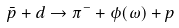<formula> <loc_0><loc_0><loc_500><loc_500>\bar { p } + d \to \pi ^ { - } + \phi ( \omega ) + p</formula> 